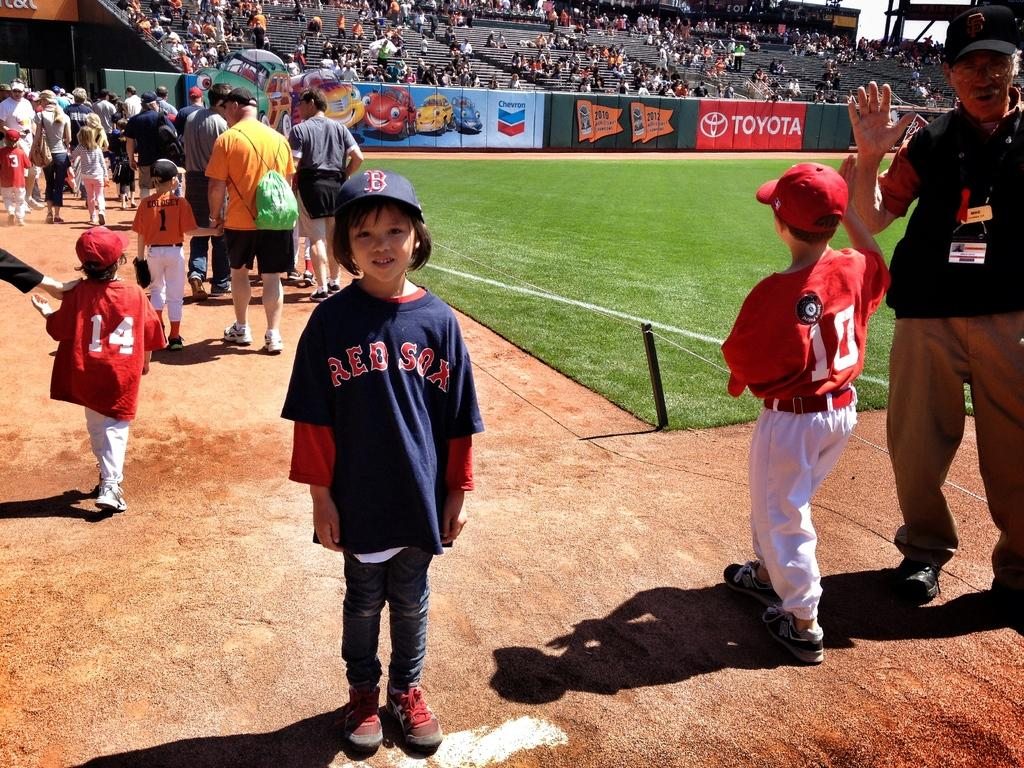<image>
Present a compact description of the photo's key features. Boy wearing a blue Red Sox jersey posing for a photo. 